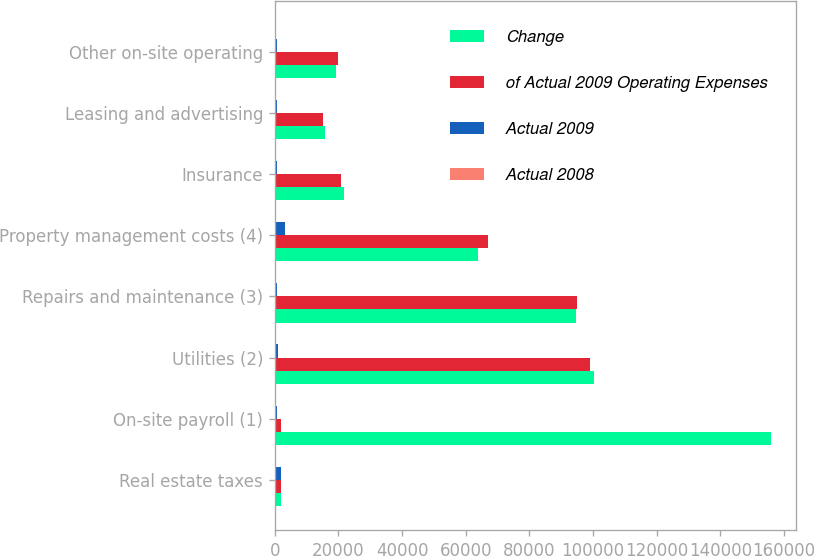Convert chart to OTSL. <chart><loc_0><loc_0><loc_500><loc_500><stacked_bar_chart><ecel><fcel>Real estate taxes<fcel>On-site payroll (1)<fcel>Utilities (2)<fcel>Repairs and maintenance (3)<fcel>Property management costs (4)<fcel>Insurance<fcel>Leasing and advertising<fcel>Other on-site operating<nl><fcel>Change<fcel>1879<fcel>155912<fcel>100184<fcel>94556<fcel>63854<fcel>21689<fcel>15664<fcel>19322<nl><fcel>of Actual 2009 Operating Expenses<fcel>1879<fcel>1879<fcel>99045<fcel>95142<fcel>67126<fcel>20890<fcel>15043<fcel>20042<nl><fcel>Actual 2009<fcel>1879<fcel>689<fcel>1139<fcel>586<fcel>3272<fcel>799<fcel>621<fcel>720<nl><fcel>Actual 2008<fcel>26.9<fcel>24.2<fcel>15.5<fcel>14.7<fcel>9.9<fcel>3.4<fcel>2.4<fcel>3<nl></chart> 